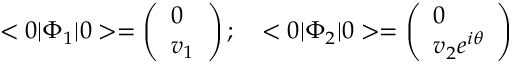Convert formula to latex. <formula><loc_0><loc_0><loc_500><loc_500>< 0 | \Phi _ { 1 } | 0 > = \left ( \begin{array} { l } { 0 } \\ { { v _ { 1 } } } \end{array} \right ) ; \quad < 0 | \Phi _ { 2 } | 0 > = \left ( \begin{array} { l } { 0 } \\ { { v _ { 2 } e ^ { i \theta } } } \end{array} \right )</formula> 